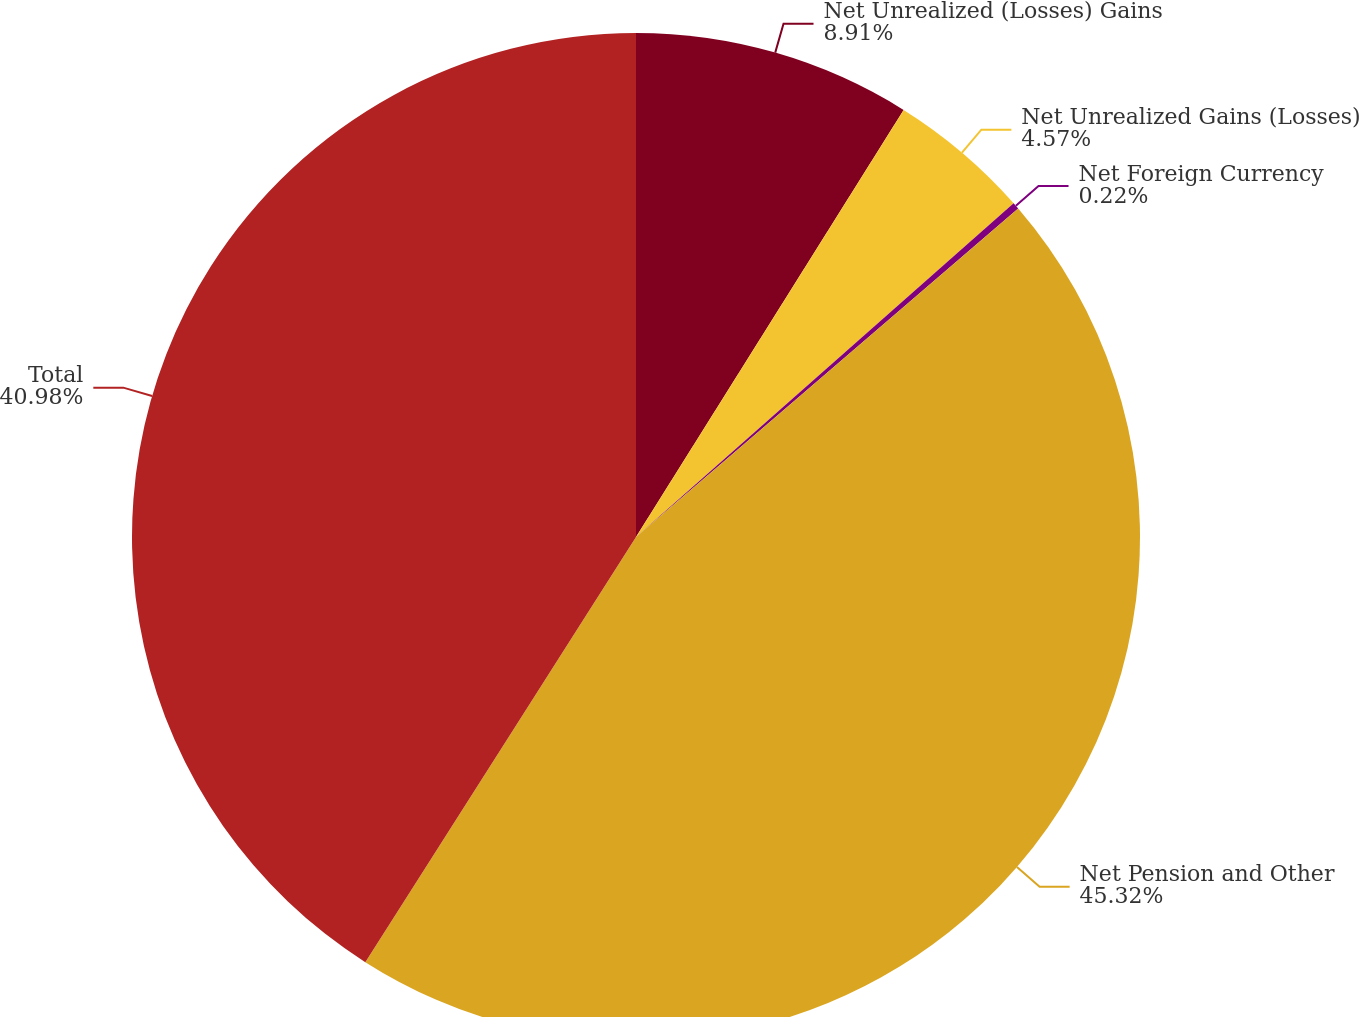Convert chart. <chart><loc_0><loc_0><loc_500><loc_500><pie_chart><fcel>Net Unrealized (Losses) Gains<fcel>Net Unrealized Gains (Losses)<fcel>Net Foreign Currency<fcel>Net Pension and Other<fcel>Total<nl><fcel>8.91%<fcel>4.57%<fcel>0.22%<fcel>45.33%<fcel>40.98%<nl></chart> 